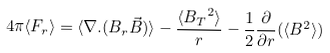Convert formula to latex. <formula><loc_0><loc_0><loc_500><loc_500>4 \pi \langle F _ { r } \rangle = \langle \nabla . ( B _ { r } \vec { B } ) \rangle - \frac { \langle { B _ { T } } ^ { 2 } \rangle } { r } - \frac { 1 } { 2 } \frac { \partial } { \partial r } ( \langle B ^ { 2 } \rangle )</formula> 